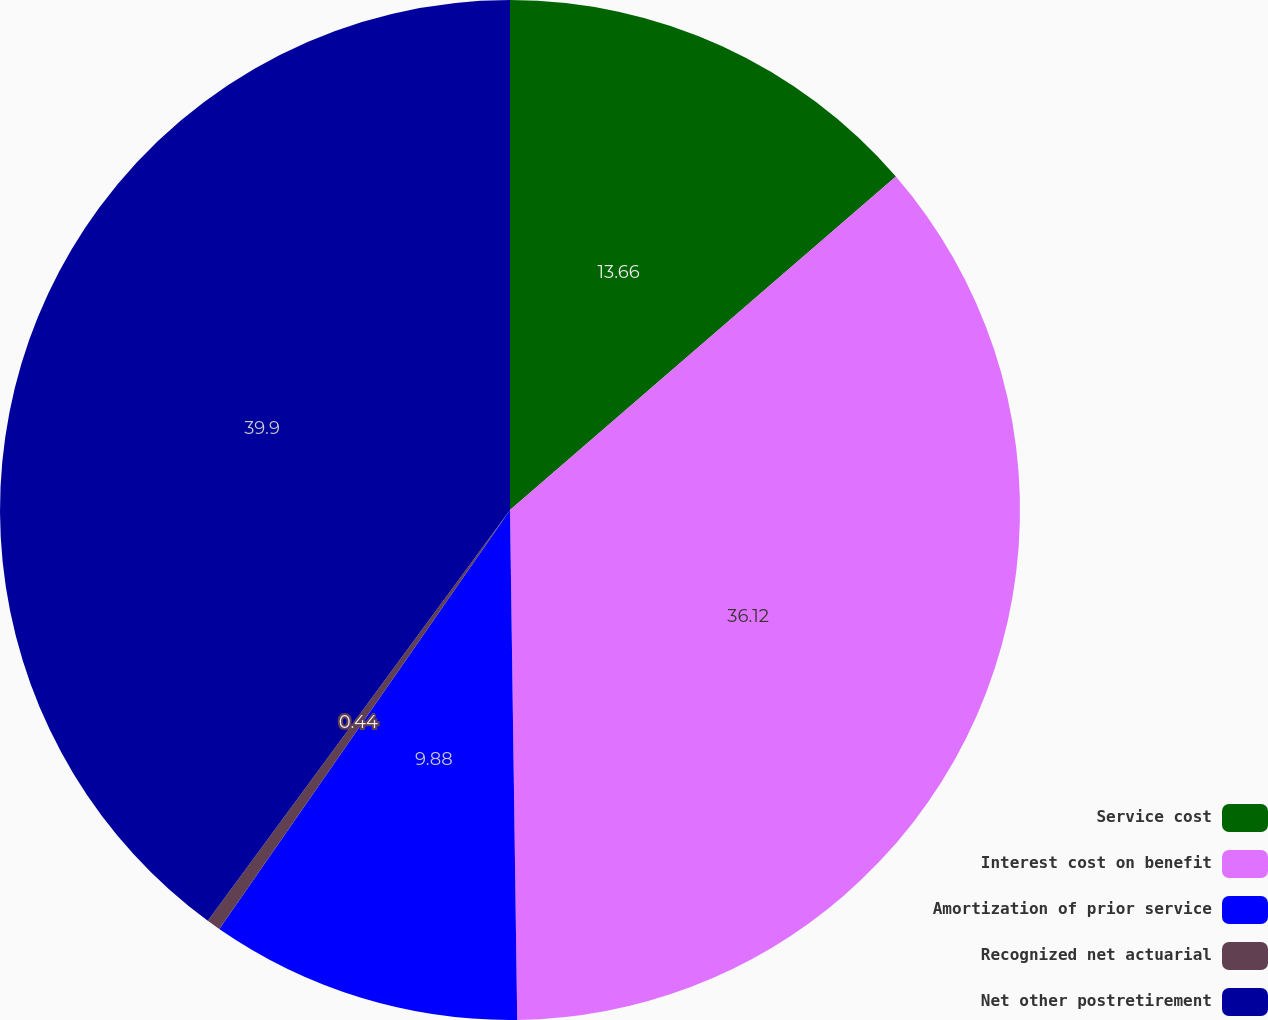Convert chart to OTSL. <chart><loc_0><loc_0><loc_500><loc_500><pie_chart><fcel>Service cost<fcel>Interest cost on benefit<fcel>Amortization of prior service<fcel>Recognized net actuarial<fcel>Net other postretirement<nl><fcel>13.66%<fcel>36.12%<fcel>9.88%<fcel>0.44%<fcel>39.91%<nl></chart> 